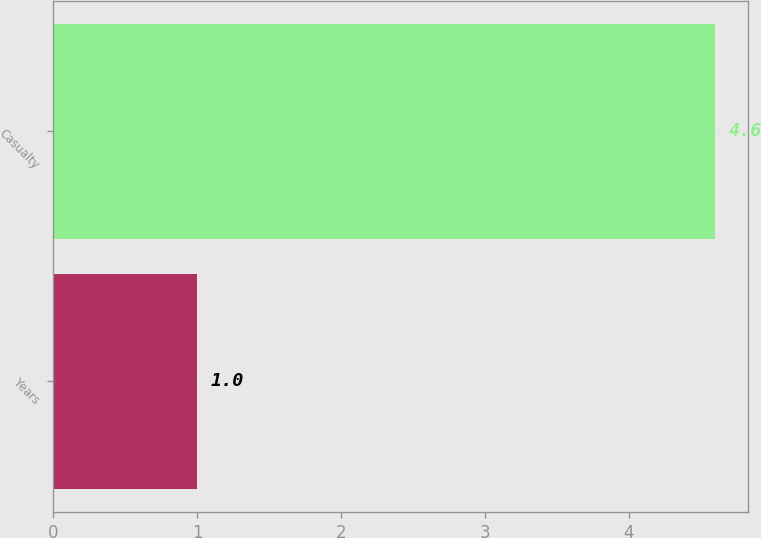Convert chart to OTSL. <chart><loc_0><loc_0><loc_500><loc_500><bar_chart><fcel>Years<fcel>Casualty<nl><fcel>1<fcel>4.6<nl></chart> 